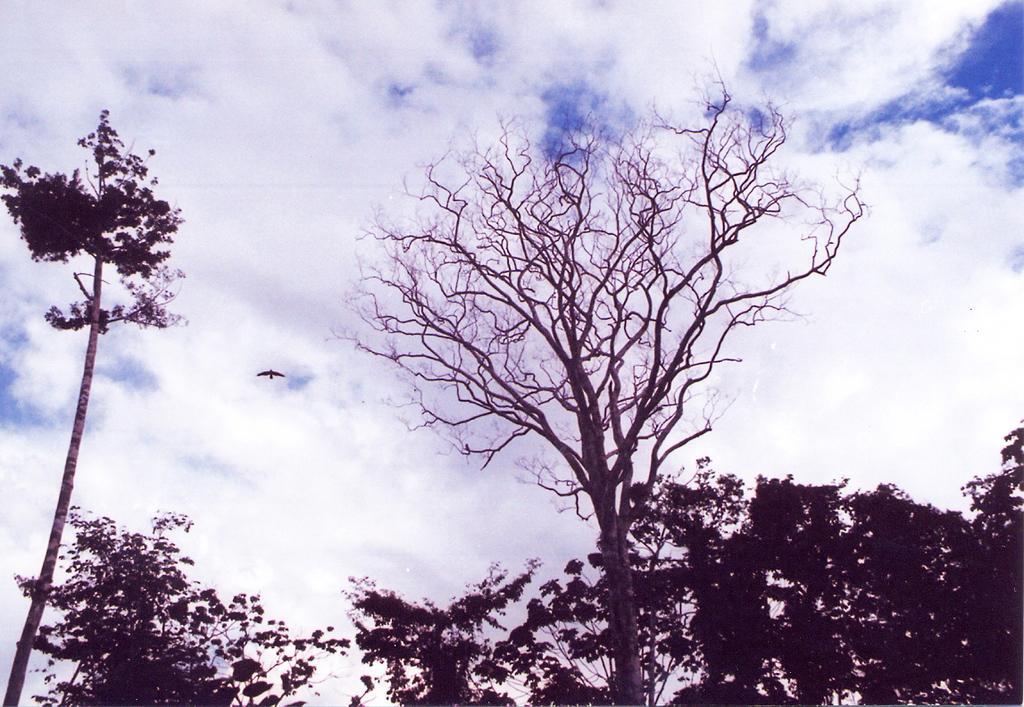Can you describe this image briefly? In this image we can see some trees, one bird flying and there is the cloudy sky in the background. 